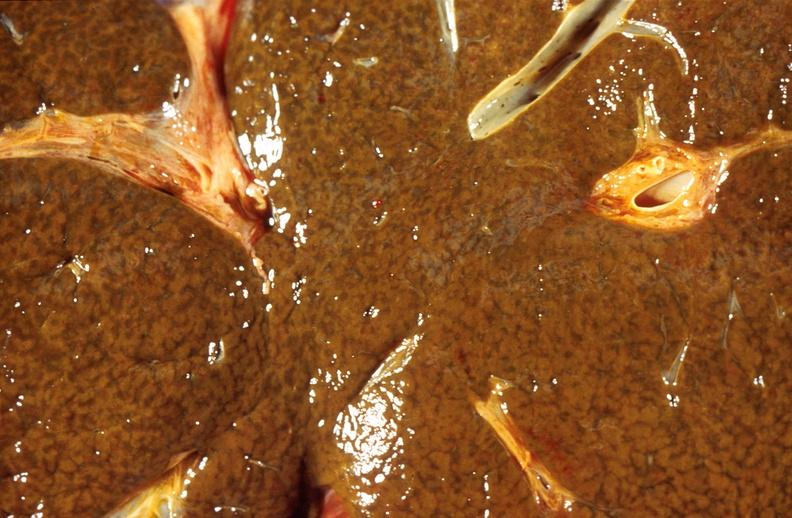does this image show liver, cholestasis and cirrhosis in a patient with cystic fibrosis?
Answer the question using a single word or phrase. Yes 